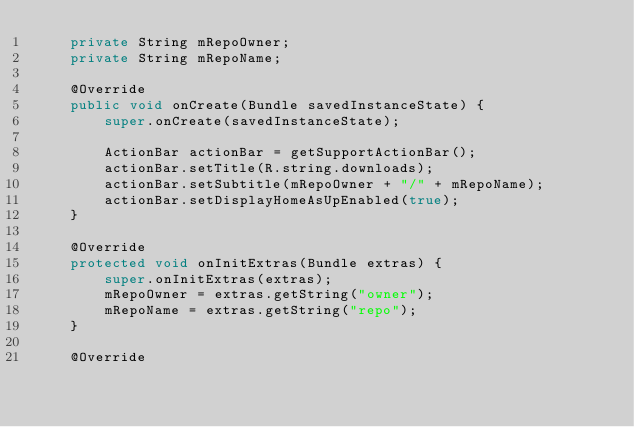Convert code to text. <code><loc_0><loc_0><loc_500><loc_500><_Java_>    private String mRepoOwner;
    private String mRepoName;

    @Override
    public void onCreate(Bundle savedInstanceState) {
        super.onCreate(savedInstanceState);

        ActionBar actionBar = getSupportActionBar();
        actionBar.setTitle(R.string.downloads);
        actionBar.setSubtitle(mRepoOwner + "/" + mRepoName);
        actionBar.setDisplayHomeAsUpEnabled(true);
    }

    @Override
    protected void onInitExtras(Bundle extras) {
        super.onInitExtras(extras);
        mRepoOwner = extras.getString("owner");
        mRepoName = extras.getString("repo");
    }

    @Override</code> 